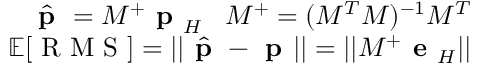<formula> <loc_0><loc_0><loc_500><loc_500>\begin{array} { r } { \hat { p } = M ^ { + } p _ { H } \, M ^ { + } = ( M ^ { T } M ) ^ { - 1 } M ^ { T } } \\ { \mathbb { E } [ R M S ] = | | \hat { p } - p | | = | | M ^ { + } e _ { H } | | } \end{array}</formula> 